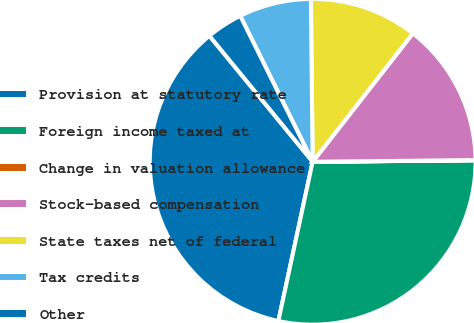Convert chart. <chart><loc_0><loc_0><loc_500><loc_500><pie_chart><fcel>Provision at statutory rate<fcel>Foreign income taxed at<fcel>Change in valuation allowance<fcel>Stock-based compensation<fcel>State taxes net of federal<fcel>Tax credits<fcel>Other<nl><fcel>35.7%<fcel>28.52%<fcel>0.02%<fcel>14.29%<fcel>10.72%<fcel>7.16%<fcel>3.59%<nl></chart> 